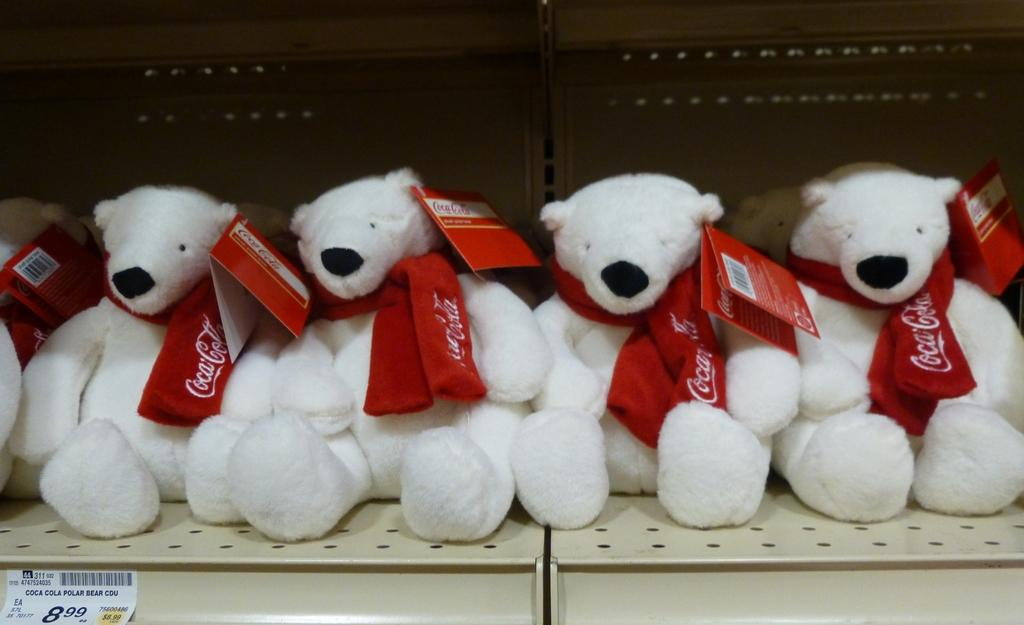What objects are present on the surface in the image? There are toys on a surface in the image. Can you describe the toys in more detail? Unfortunately, the image does not provide enough detail to describe the toys further. What might the toys be used for? The toys are likely meant for play or entertainment. How does the image convey a sense of quiet in the room? The image does not convey a sense of quiet in the room, as there is no information about the room's ambiance or noise level. 